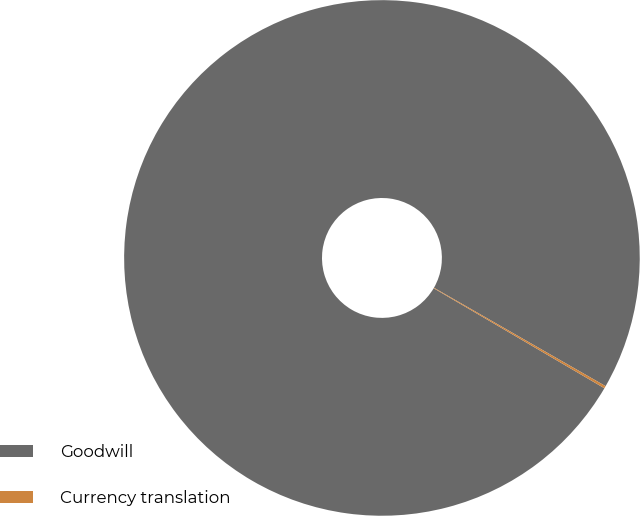Convert chart to OTSL. <chart><loc_0><loc_0><loc_500><loc_500><pie_chart><fcel>Goodwill<fcel>Currency translation<nl><fcel>99.85%<fcel>0.15%<nl></chart> 